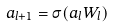<formula> <loc_0><loc_0><loc_500><loc_500>a _ { l + 1 } = \sigma ( a _ { l } W _ { l } )</formula> 